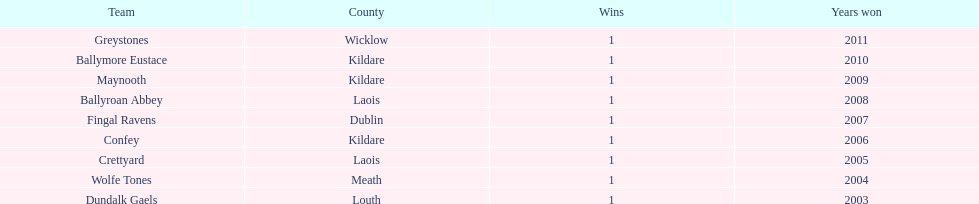What is the total of wins on the chart 9. 